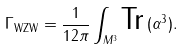<formula> <loc_0><loc_0><loc_500><loc_500>\Gamma _ { \text {WZW} } = \frac { 1 } { 1 2 \pi } \int _ { M ^ { 3 } } \text {Tr} \, ( \alpha ^ { 3 } ) .</formula> 